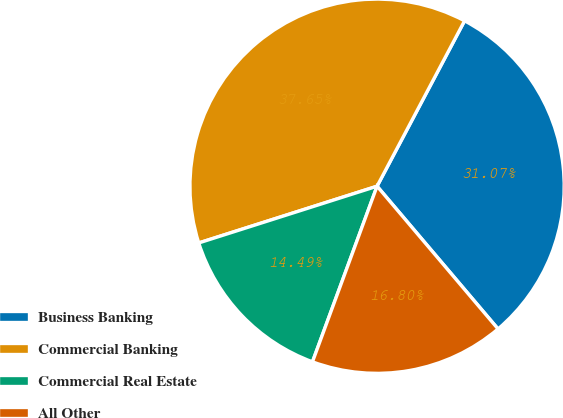Convert chart to OTSL. <chart><loc_0><loc_0><loc_500><loc_500><pie_chart><fcel>Business Banking<fcel>Commercial Banking<fcel>Commercial Real Estate<fcel>All Other<nl><fcel>31.07%<fcel>37.65%<fcel>14.49%<fcel>16.8%<nl></chart> 